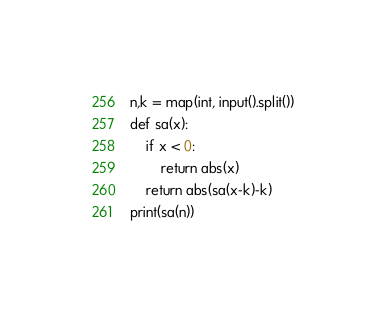Convert code to text. <code><loc_0><loc_0><loc_500><loc_500><_Python_>n,k = map(int, input().split())
def sa(x):
    if x < 0:
        return abs(x)
    return abs(sa(x-k)-k)
print(sa(n))</code> 